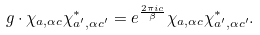Convert formula to latex. <formula><loc_0><loc_0><loc_500><loc_500>g \cdot \chi _ { a , \alpha c } \chi _ { a ^ { \prime } , \alpha c ^ { \prime } } ^ { * } = e ^ { \frac { 2 \pi i c } { \beta } } \chi _ { a , \alpha c } \chi _ { a ^ { \prime } , \alpha c ^ { \prime } } ^ { * } .</formula> 